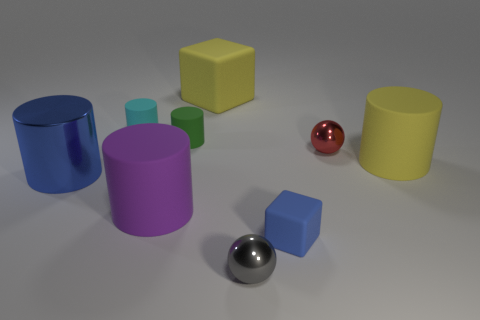Subtract all yellow cylinders. How many cylinders are left? 4 Subtract all blue shiny cylinders. How many cylinders are left? 4 Subtract all green cylinders. Subtract all cyan cubes. How many cylinders are left? 4 Add 1 metallic cylinders. How many objects exist? 10 Subtract all cylinders. How many objects are left? 4 Subtract all red balls. Subtract all blue metal objects. How many objects are left? 7 Add 8 large purple cylinders. How many large purple cylinders are left? 9 Add 9 large purple objects. How many large purple objects exist? 10 Subtract 0 brown cylinders. How many objects are left? 9 